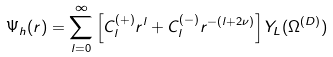<formula> <loc_0><loc_0><loc_500><loc_500>\Psi _ { h } ( { r } ) = \sum _ { l = 0 } ^ { \infty } \left [ C ^ { ( + ) } _ { l } r ^ { l } + C ^ { ( - ) } _ { l } r ^ { - ( l + 2 \nu ) } \right ] Y _ { L } ( \Omega ^ { ( D ) } ) \,</formula> 